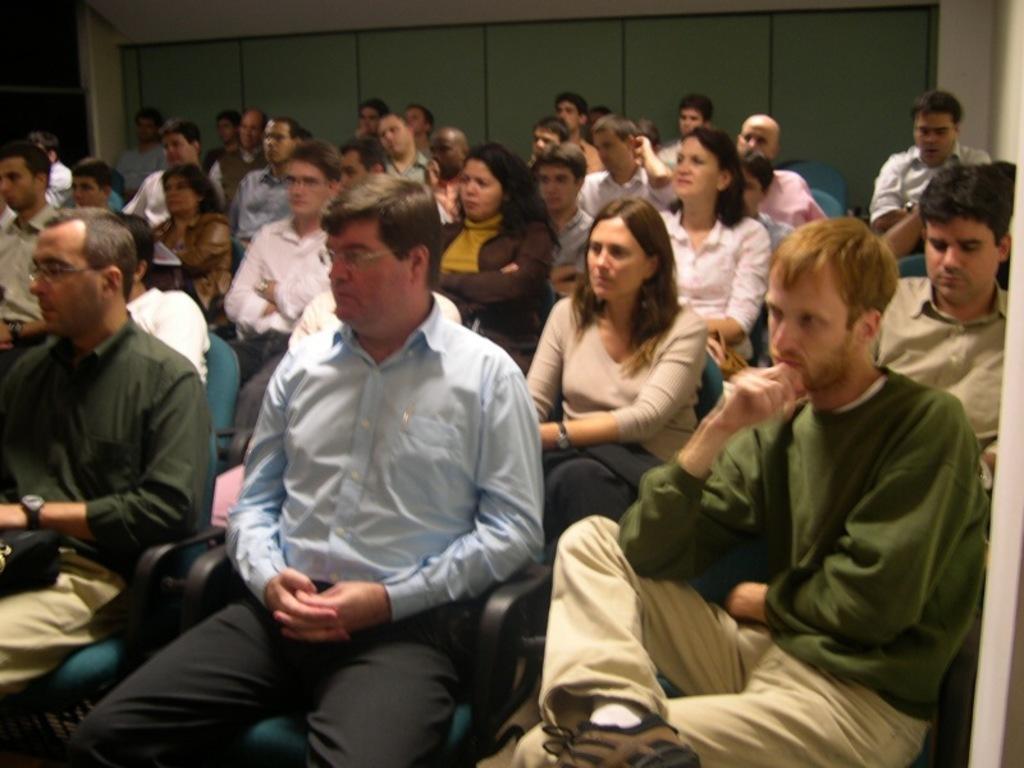Please provide a concise description of this image. In this image there are people sitting in the chairs one beside the other in the rows. In the background there is a wall. 